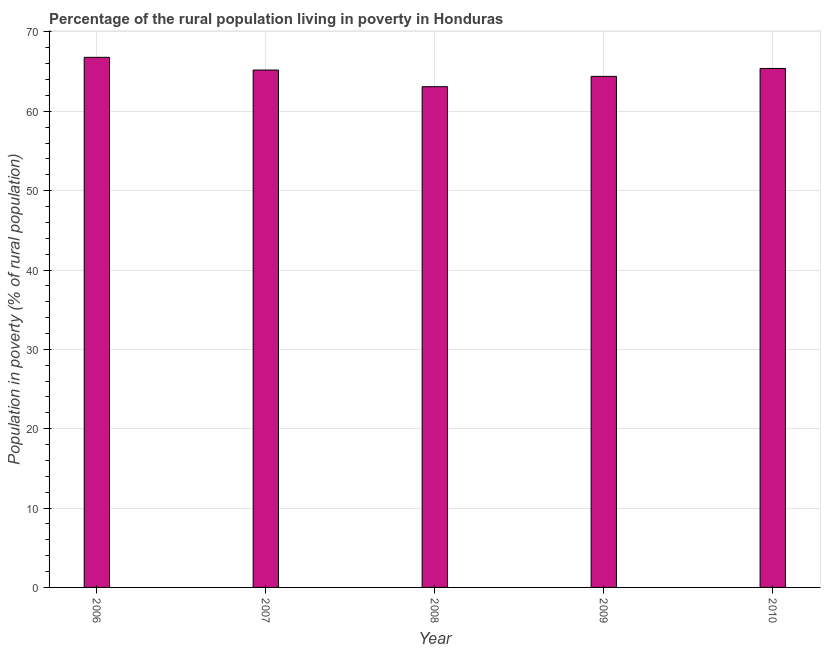What is the title of the graph?
Your response must be concise. Percentage of the rural population living in poverty in Honduras. What is the label or title of the X-axis?
Your response must be concise. Year. What is the label or title of the Y-axis?
Offer a terse response. Population in poverty (% of rural population). What is the percentage of rural population living below poverty line in 2006?
Offer a terse response. 66.8. Across all years, what is the maximum percentage of rural population living below poverty line?
Provide a short and direct response. 66.8. Across all years, what is the minimum percentage of rural population living below poverty line?
Ensure brevity in your answer.  63.1. In which year was the percentage of rural population living below poverty line maximum?
Provide a succinct answer. 2006. What is the sum of the percentage of rural population living below poverty line?
Provide a short and direct response. 324.9. What is the difference between the percentage of rural population living below poverty line in 2006 and 2010?
Offer a terse response. 1.4. What is the average percentage of rural population living below poverty line per year?
Provide a short and direct response. 64.98. What is the median percentage of rural population living below poverty line?
Make the answer very short. 65.2. In how many years, is the percentage of rural population living below poverty line greater than 34 %?
Offer a terse response. 5. Is the percentage of rural population living below poverty line in 2006 less than that in 2007?
Your answer should be compact. No. Is the difference between the percentage of rural population living below poverty line in 2006 and 2007 greater than the difference between any two years?
Give a very brief answer. No. What is the difference between the highest and the second highest percentage of rural population living below poverty line?
Your response must be concise. 1.4. Is the sum of the percentage of rural population living below poverty line in 2006 and 2010 greater than the maximum percentage of rural population living below poverty line across all years?
Make the answer very short. Yes. In how many years, is the percentage of rural population living below poverty line greater than the average percentage of rural population living below poverty line taken over all years?
Provide a short and direct response. 3. How many bars are there?
Make the answer very short. 5. How many years are there in the graph?
Offer a very short reply. 5. Are the values on the major ticks of Y-axis written in scientific E-notation?
Give a very brief answer. No. What is the Population in poverty (% of rural population) of 2006?
Give a very brief answer. 66.8. What is the Population in poverty (% of rural population) of 2007?
Provide a short and direct response. 65.2. What is the Population in poverty (% of rural population) of 2008?
Your answer should be very brief. 63.1. What is the Population in poverty (% of rural population) of 2009?
Keep it short and to the point. 64.4. What is the Population in poverty (% of rural population) of 2010?
Provide a succinct answer. 65.4. What is the difference between the Population in poverty (% of rural population) in 2006 and 2009?
Your answer should be compact. 2.4. What is the difference between the Population in poverty (% of rural population) in 2007 and 2009?
Give a very brief answer. 0.8. What is the difference between the Population in poverty (% of rural population) in 2008 and 2009?
Make the answer very short. -1.3. What is the ratio of the Population in poverty (% of rural population) in 2006 to that in 2008?
Make the answer very short. 1.06. What is the ratio of the Population in poverty (% of rural population) in 2007 to that in 2008?
Offer a very short reply. 1.03. What is the ratio of the Population in poverty (% of rural population) in 2007 to that in 2009?
Ensure brevity in your answer.  1.01. What is the ratio of the Population in poverty (% of rural population) in 2007 to that in 2010?
Your answer should be compact. 1. What is the ratio of the Population in poverty (% of rural population) in 2008 to that in 2009?
Your answer should be compact. 0.98. 